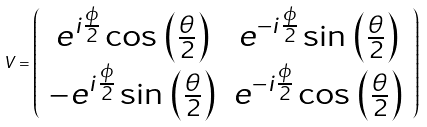<formula> <loc_0><loc_0><loc_500><loc_500>V = \left ( \begin{array} { c c } e ^ { i \frac { \phi } { 2 } } \cos \, \left ( \frac { \theta } { 2 } \right ) & e ^ { - i \frac { \phi } { 2 } } \sin \, \left ( \frac { \theta } { 2 } \right ) \\ - e ^ { i \frac { \phi } { 2 } } \sin \, \left ( \frac { \theta } { 2 } \right ) & e ^ { - i \frac { \phi } { 2 } } \cos \, \left ( \frac { \theta } { 2 } \right ) \end{array} \right )</formula> 